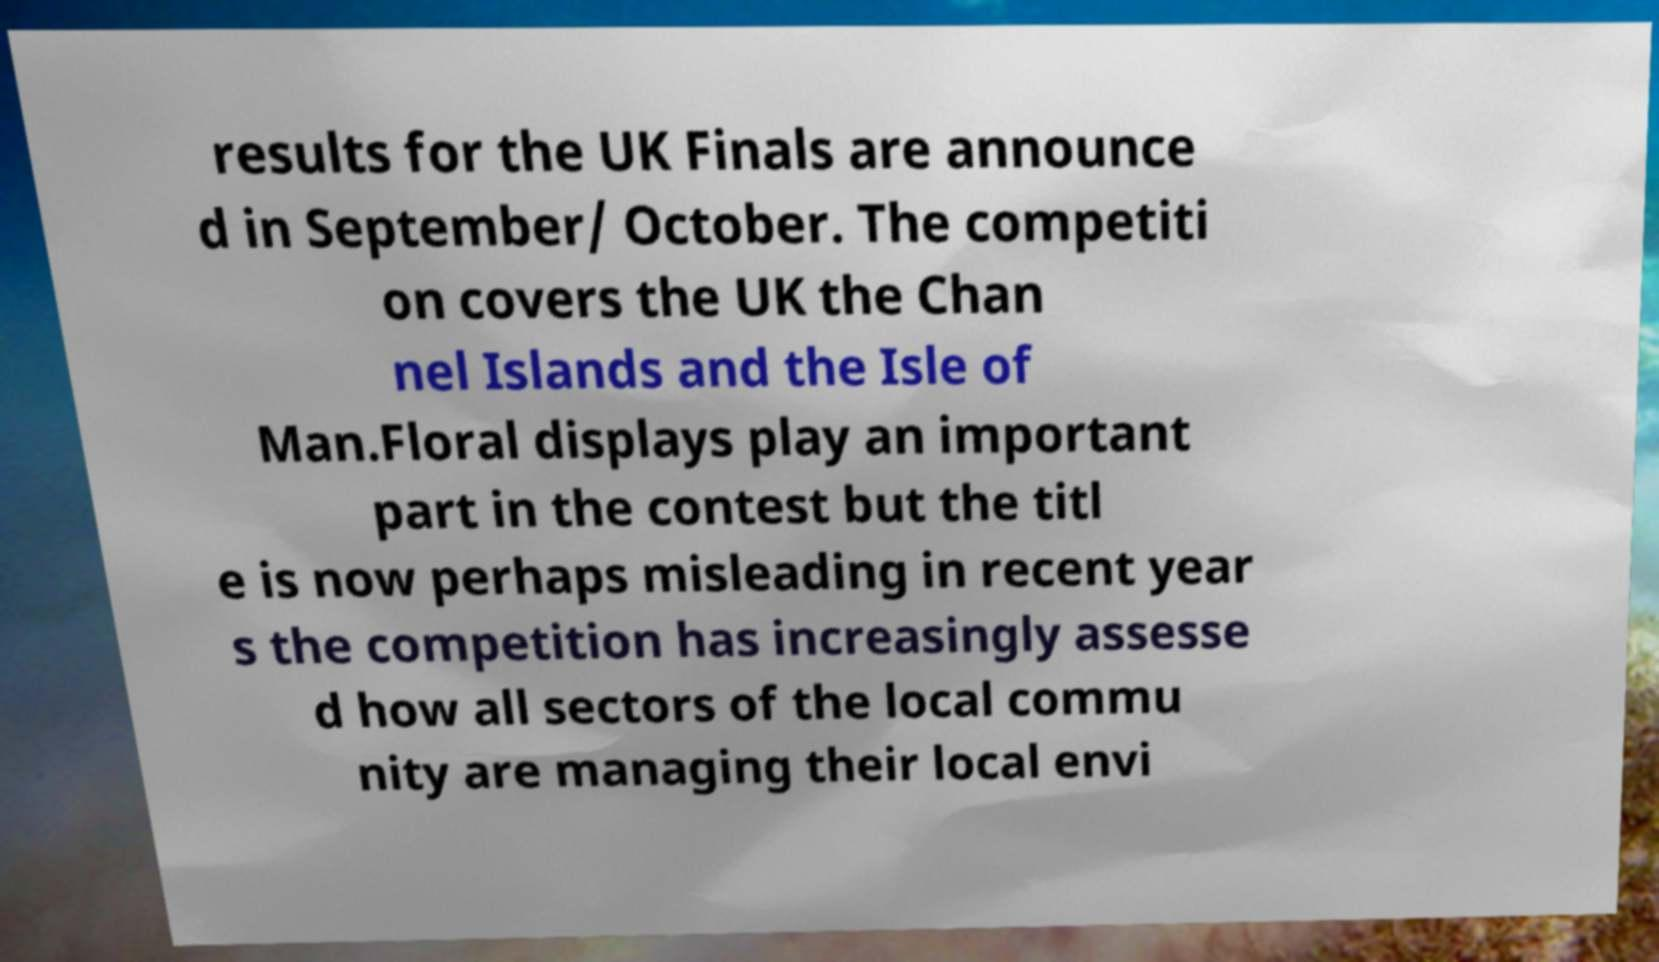What messages or text are displayed in this image? I need them in a readable, typed format. results for the UK Finals are announce d in September/ October. The competiti on covers the UK the Chan nel Islands and the Isle of Man.Floral displays play an important part in the contest but the titl e is now perhaps misleading in recent year s the competition has increasingly assesse d how all sectors of the local commu nity are managing their local envi 